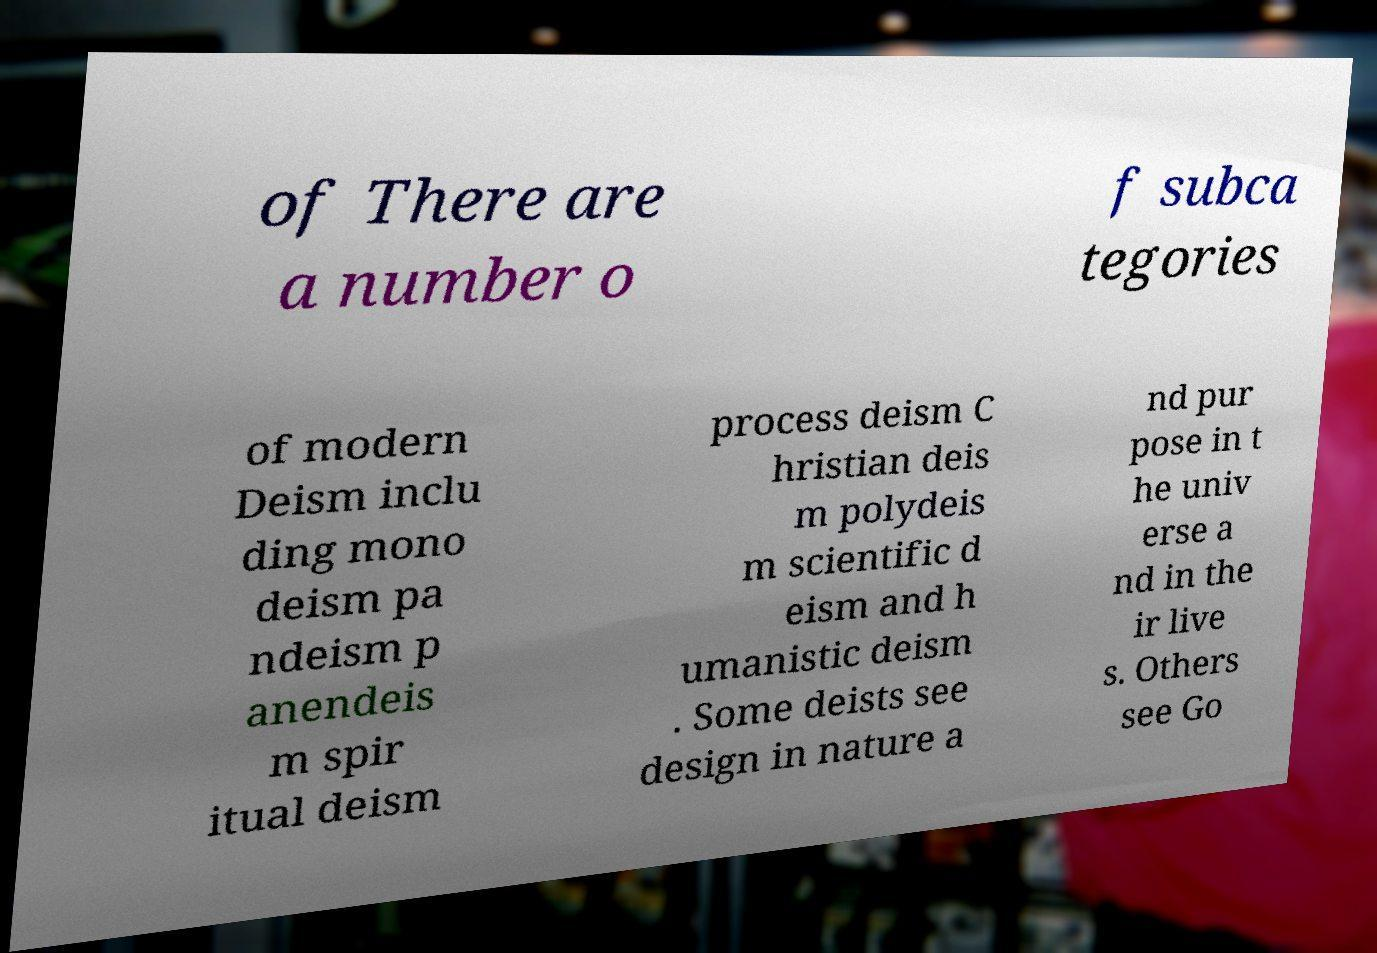Can you read and provide the text displayed in the image?This photo seems to have some interesting text. Can you extract and type it out for me? of There are a number o f subca tegories of modern Deism inclu ding mono deism pa ndeism p anendeis m spir itual deism process deism C hristian deis m polydeis m scientific d eism and h umanistic deism . Some deists see design in nature a nd pur pose in t he univ erse a nd in the ir live s. Others see Go 